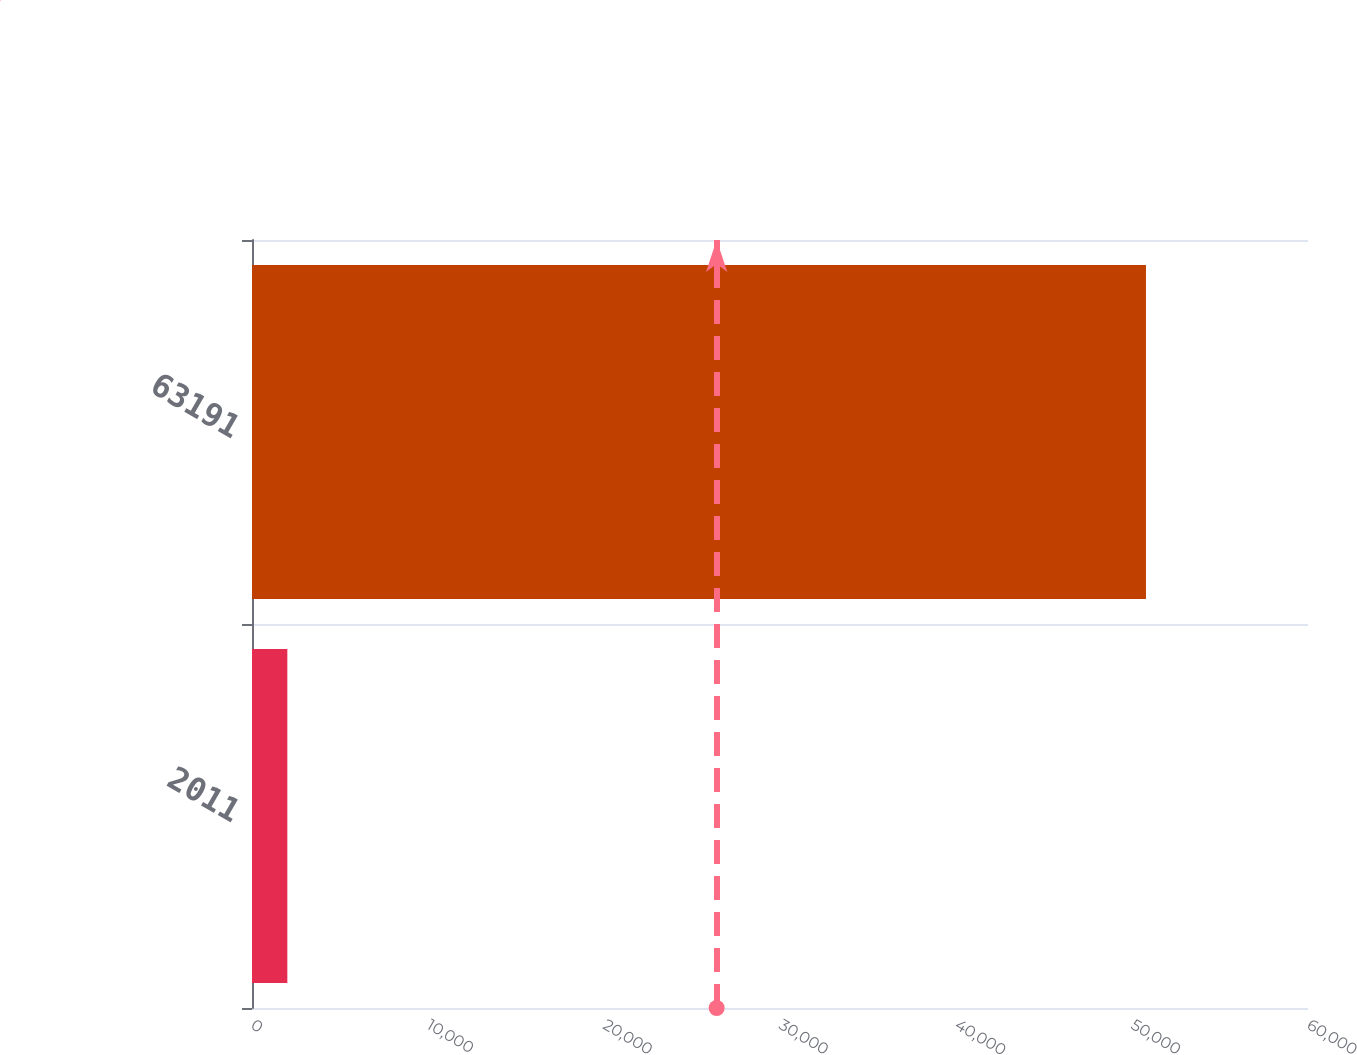Convert chart. <chart><loc_0><loc_0><loc_500><loc_500><bar_chart><fcel>2011<fcel>63191<nl><fcel>2008<fcel>50794<nl></chart> 